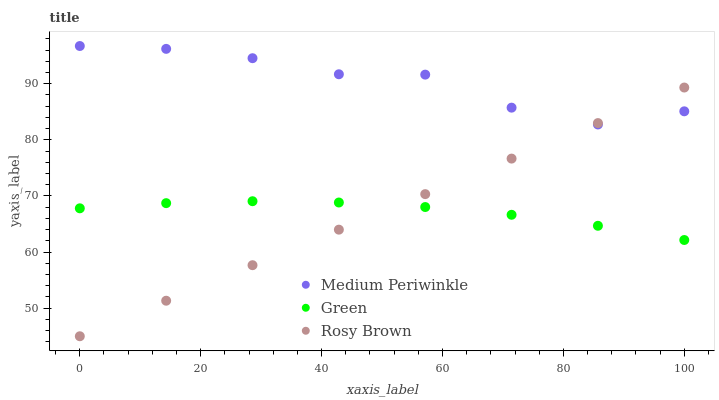Does Rosy Brown have the minimum area under the curve?
Answer yes or no. Yes. Does Medium Periwinkle have the maximum area under the curve?
Answer yes or no. Yes. Does Medium Periwinkle have the minimum area under the curve?
Answer yes or no. No. Does Rosy Brown have the maximum area under the curve?
Answer yes or no. No. Is Rosy Brown the smoothest?
Answer yes or no. Yes. Is Medium Periwinkle the roughest?
Answer yes or no. Yes. Is Medium Periwinkle the smoothest?
Answer yes or no. No. Is Rosy Brown the roughest?
Answer yes or no. No. Does Rosy Brown have the lowest value?
Answer yes or no. Yes. Does Medium Periwinkle have the lowest value?
Answer yes or no. No. Does Medium Periwinkle have the highest value?
Answer yes or no. Yes. Does Rosy Brown have the highest value?
Answer yes or no. No. Is Green less than Medium Periwinkle?
Answer yes or no. Yes. Is Medium Periwinkle greater than Green?
Answer yes or no. Yes. Does Green intersect Rosy Brown?
Answer yes or no. Yes. Is Green less than Rosy Brown?
Answer yes or no. No. Is Green greater than Rosy Brown?
Answer yes or no. No. Does Green intersect Medium Periwinkle?
Answer yes or no. No. 